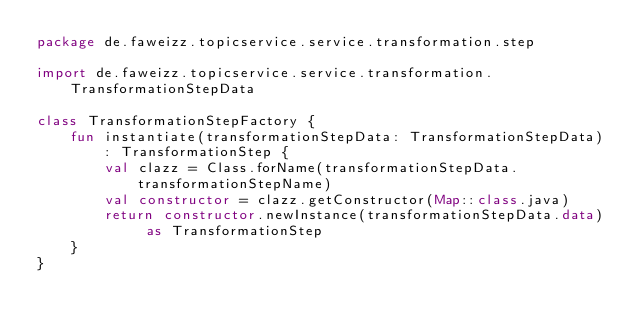Convert code to text. <code><loc_0><loc_0><loc_500><loc_500><_Kotlin_>package de.faweizz.topicservice.service.transformation.step

import de.faweizz.topicservice.service.transformation.TransformationStepData

class TransformationStepFactory {
    fun instantiate(transformationStepData: TransformationStepData): TransformationStep {
        val clazz = Class.forName(transformationStepData.transformationStepName)
        val constructor = clazz.getConstructor(Map::class.java)
        return constructor.newInstance(transformationStepData.data) as TransformationStep
    }
}</code> 